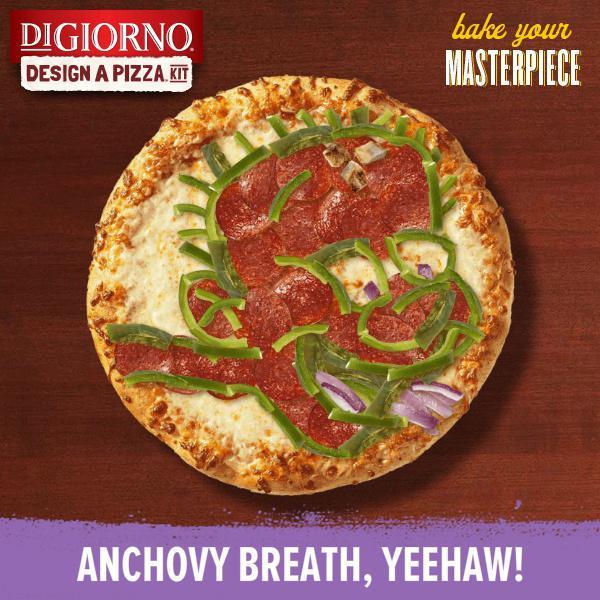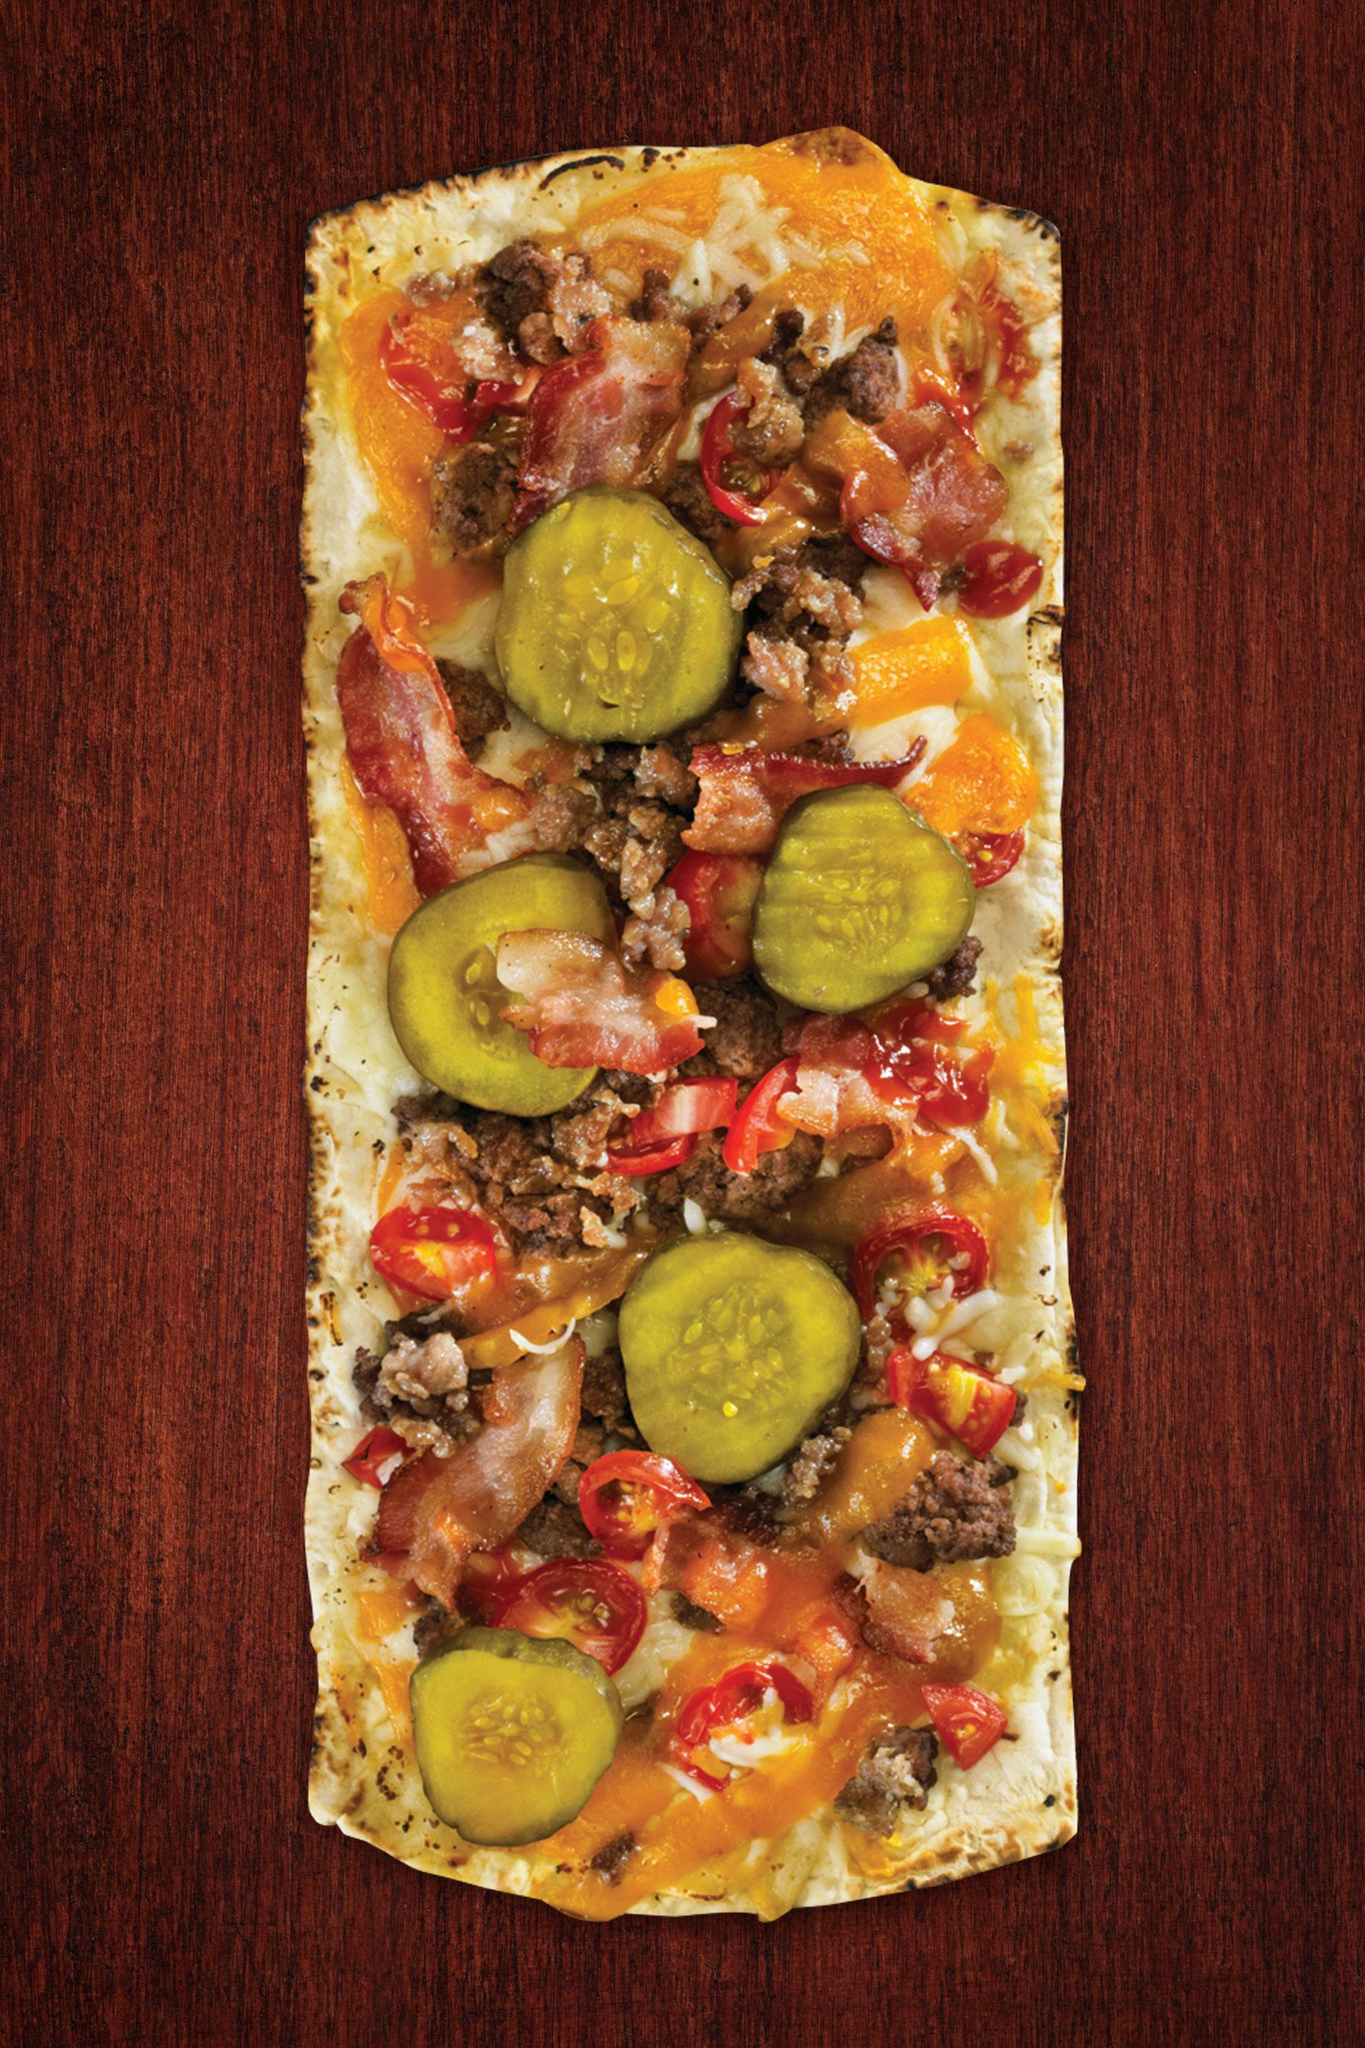The first image is the image on the left, the second image is the image on the right. Examine the images to the left and right. Is the description "There is at least one rectangular shaped pizza." accurate? Answer yes or no. Yes. The first image is the image on the left, the second image is the image on the right. Evaluate the accuracy of this statement regarding the images: "One image shows a round pizza with none of its slices missing, sitting in an open cardboard box positioned with the lid at the top.". Is it true? Answer yes or no. No. 